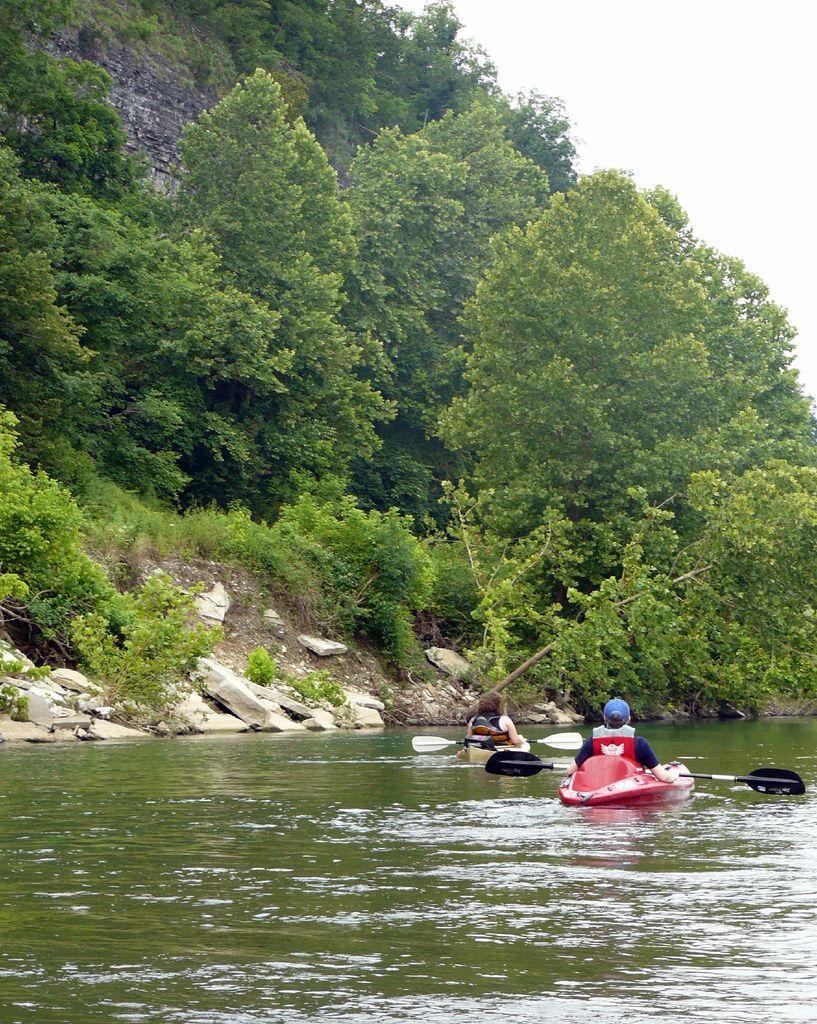In one or two sentences, can you explain what this image depicts? In this image we can see there are rocks, trees and the sky. And there are boats on the water and persons sitting on the boats and holding paddles. 